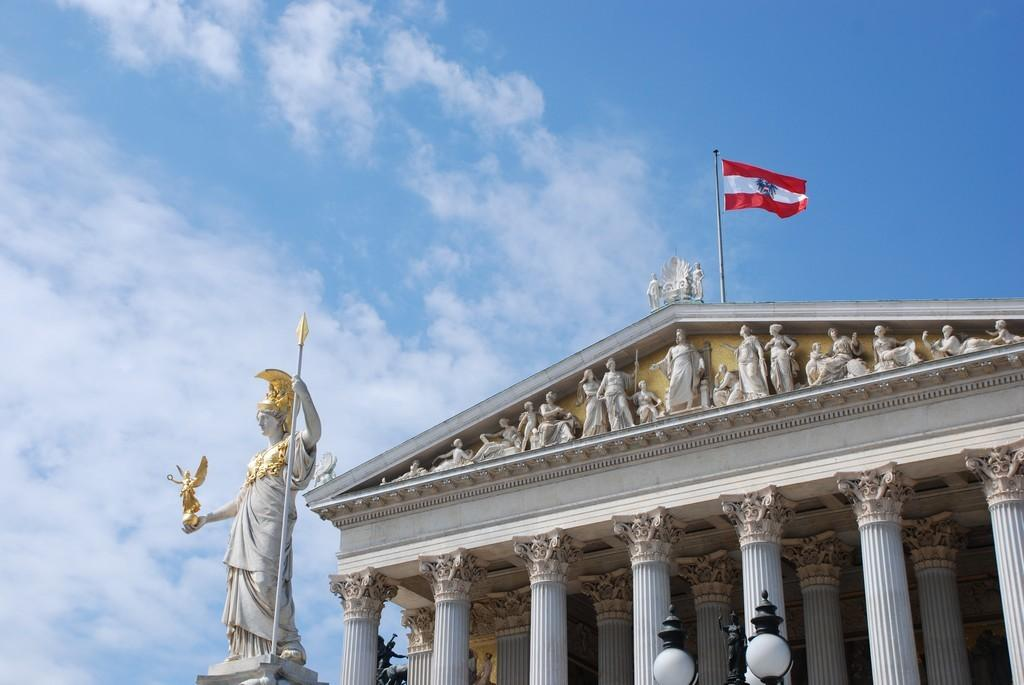What type of structure is visible in the image? There is a building in the image. What decorative elements can be seen on the building? There are statues and pillars visible on the building. What additional features are present on the building? There are lights and a flag at the top of the building. What can be seen in the background of the image? The sky is visible in the background of the image, and clouds are present in the sky. What color is the brain that is hanging from the flagpole in the image? There is no brain present in the image; the flag is at the top of the building. How does the throat of the statue in the image appear to be functioning? There is no throat present in the image, as the subjects are statues and not living beings. 